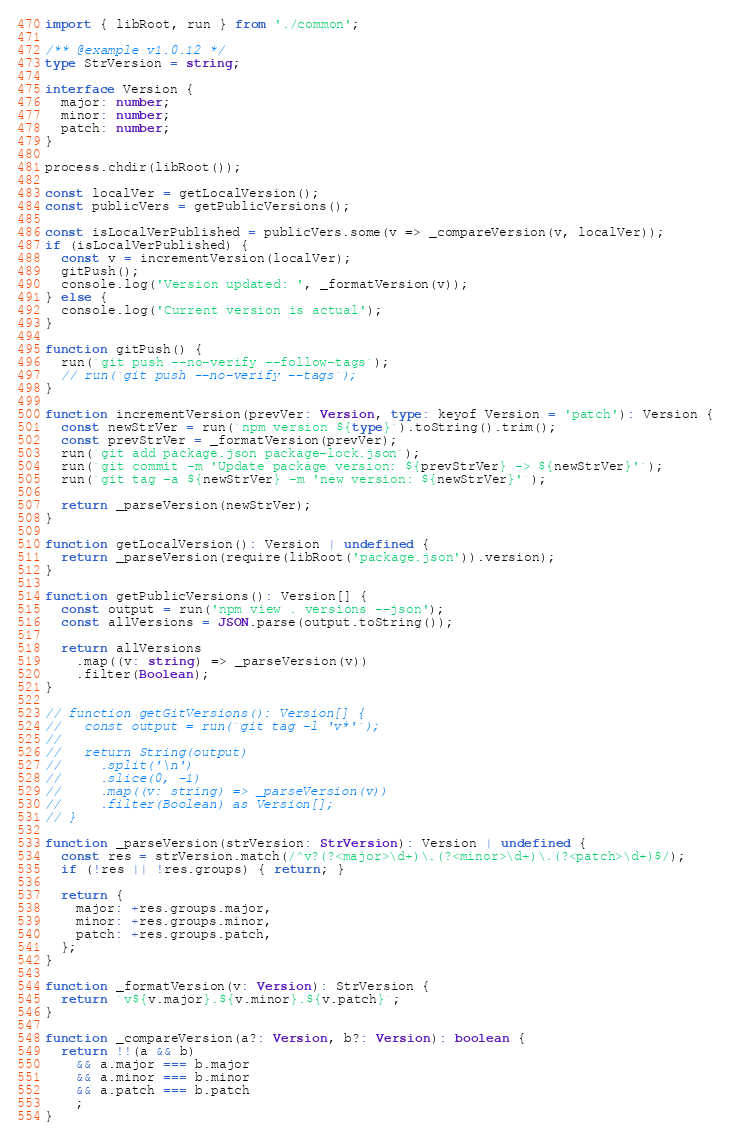Convert code to text. <code><loc_0><loc_0><loc_500><loc_500><_TypeScript_>import { libRoot, run } from './common';

/** @example v1.0.12 */
type StrVersion = string;

interface Version {
  major: number;
  minor: number;
  patch: number;
}

process.chdir(libRoot());

const localVer = getLocalVersion();
const publicVers = getPublicVersions();

const isLocalVerPublished = publicVers.some(v => _compareVersion(v, localVer));
if (isLocalVerPublished) {
  const v = incrementVersion(localVer);
  gitPush();
  console.log('Version updated: ', _formatVersion(v));
} else {
  console.log('Current version is actual');
}

function gitPush() {
  run(`git push --no-verify --follow-tags`);
  // run(`git push --no-verify --tags`);
}

function incrementVersion(prevVer: Version, type: keyof Version = 'patch'): Version {
  const newStrVer = run(`npm version ${type}`).toString().trim();
  const prevStrVer = _formatVersion(prevVer);
  run(`git add package.json package-lock.json`);
  run(`git commit -m 'Update package version: ${prevStrVer} -> ${newStrVer}'`);
  run(`git tag -a ${newStrVer} -m 'new version: ${newStrVer}'`);

  return _parseVersion(newStrVer);
}

function getLocalVersion(): Version | undefined {
  return _parseVersion(require(libRoot('package.json')).version);
}

function getPublicVersions(): Version[] {
  const output = run('npm view . versions --json');
  const allVersions = JSON.parse(output.toString());

  return allVersions
    .map((v: string) => _parseVersion(v))
    .filter(Boolean);
}

// function getGitVersions(): Version[] {
//   const output = run(`git tag -l 'v*'`);
//
//   return String(output)
//     .split('\n')
//     .slice(0, -1)
//     .map((v: string) => _parseVersion(v))
//     .filter(Boolean) as Version[];
// }

function _parseVersion(strVersion: StrVersion): Version | undefined {
  const res = strVersion.match(/^v?(?<major>\d+)\.(?<minor>\d+)\.(?<patch>\d+)$/);
  if (!res || !res.groups) { return; }

  return {
    major: +res.groups.major,
    minor: +res.groups.minor,
    patch: +res.groups.patch,
  };
}

function _formatVersion(v: Version): StrVersion {
  return `v${v.major}.${v.minor}.${v.patch}`;
}

function _compareVersion(a?: Version, b?: Version): boolean {
  return !!(a && b)
    && a.major === b.major
    && a.minor === b.minor
    && a.patch === b.patch
    ;
}
</code> 